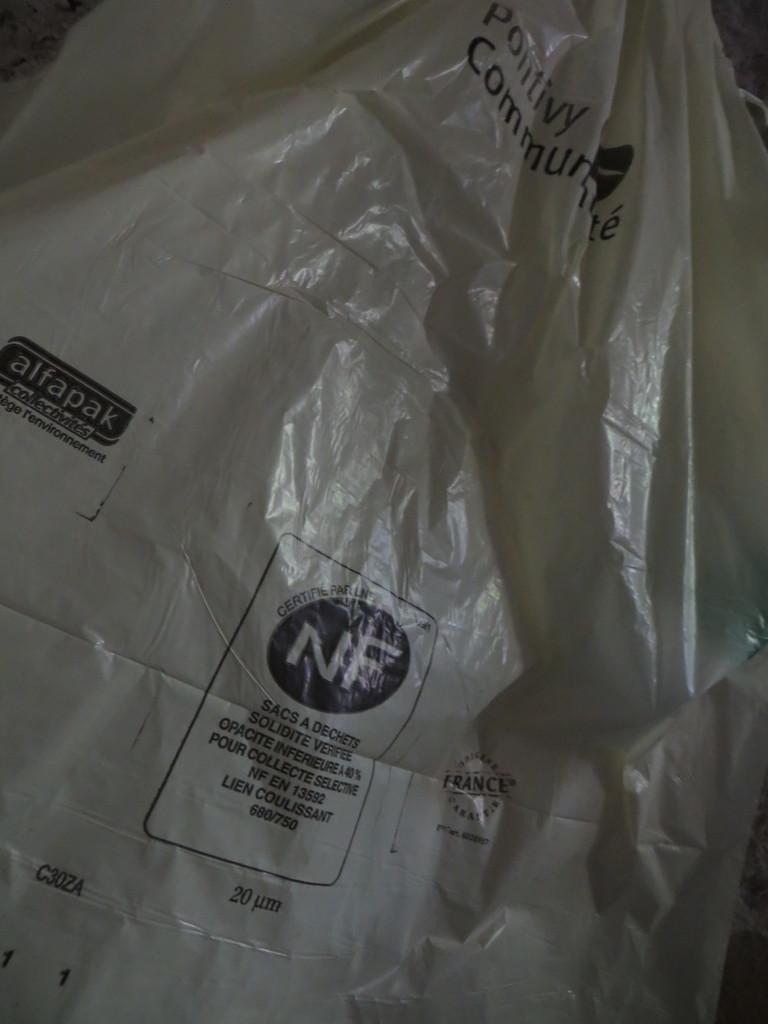How would you summarize this image in a sentence or two? This picture contains a cover having some text on it. 